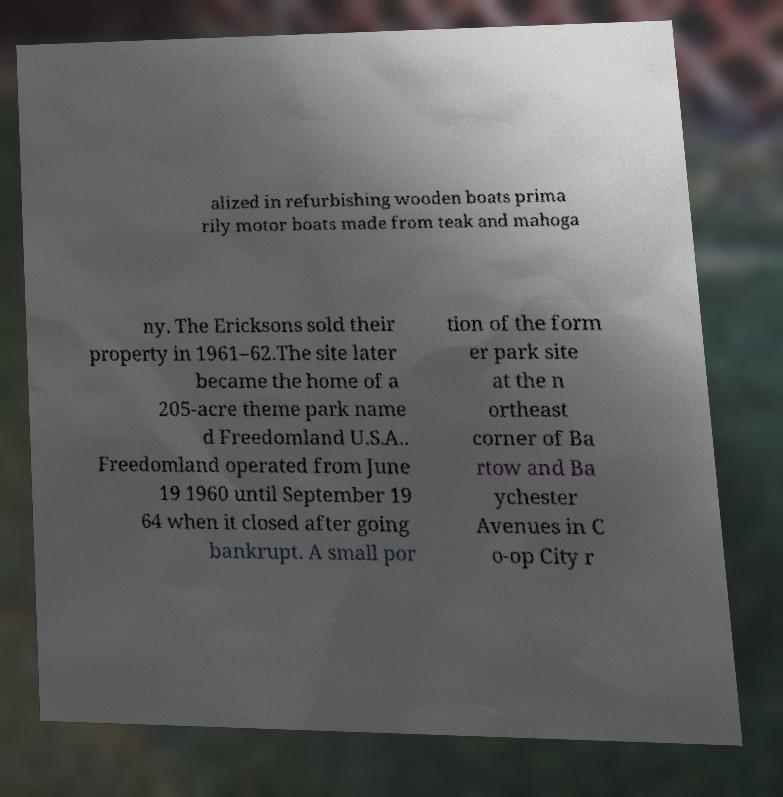Could you extract and type out the text from this image? alized in refurbishing wooden boats prima rily motor boats made from teak and mahoga ny. The Ericksons sold their property in 1961–62.The site later became the home of a 205-acre theme park name d Freedomland U.S.A.. Freedomland operated from June 19 1960 until September 19 64 when it closed after going bankrupt. A small por tion of the form er park site at the n ortheast corner of Ba rtow and Ba ychester Avenues in C o-op City r 